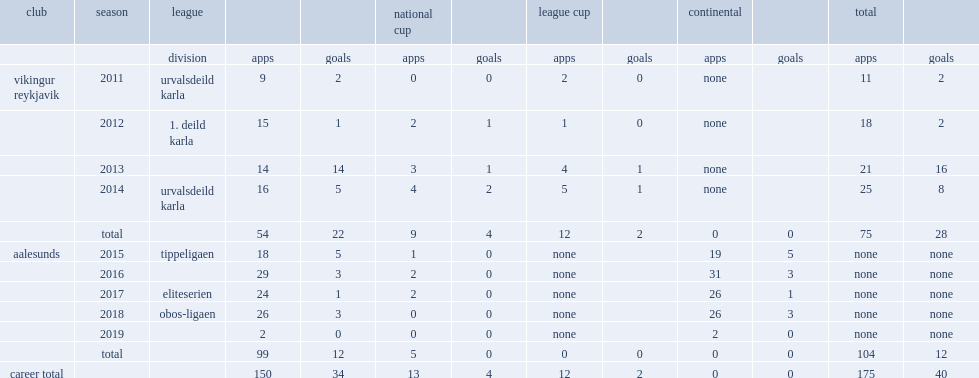Which club did aron play for in 2015? Aalesunds. 